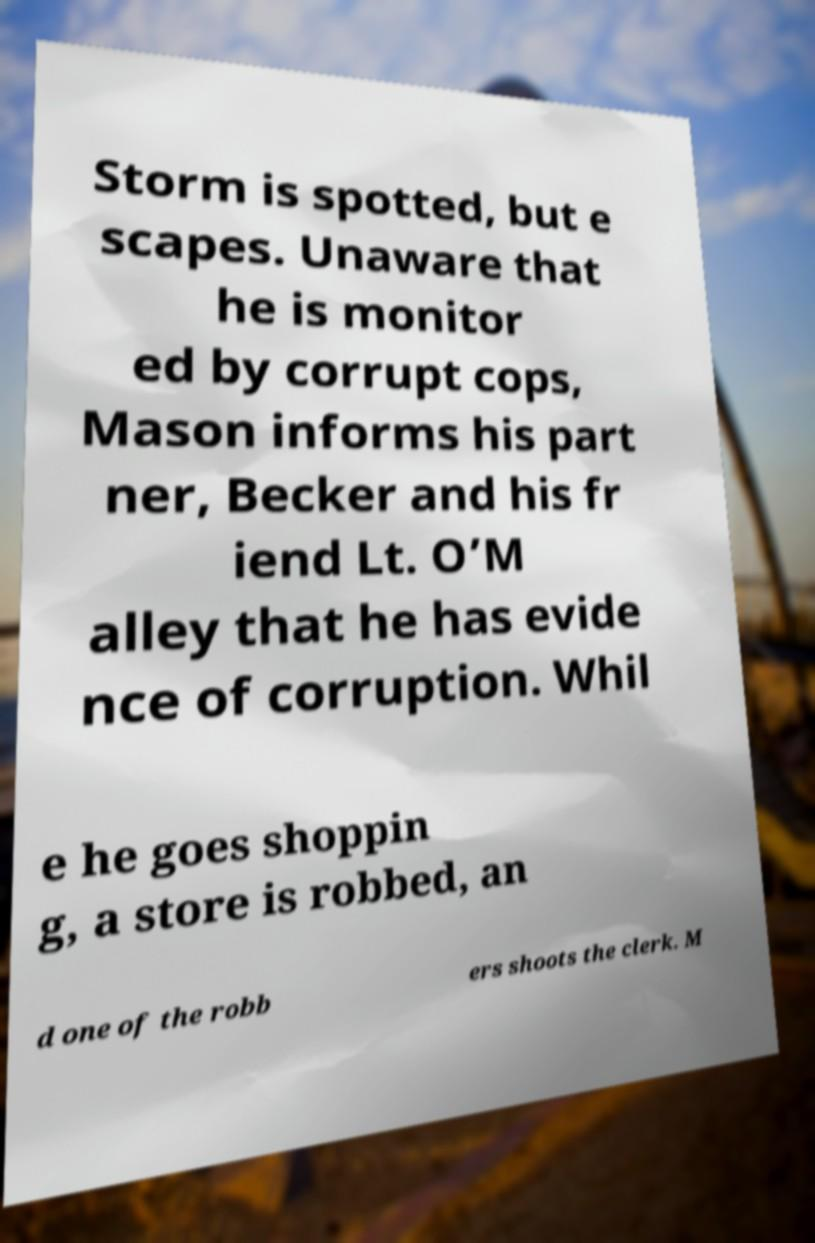For documentation purposes, I need the text within this image transcribed. Could you provide that? Storm is spotted, but e scapes. Unaware that he is monitor ed by corrupt cops, Mason informs his part ner, Becker and his fr iend Lt. O’M alley that he has evide nce of corruption. Whil e he goes shoppin g, a store is robbed, an d one of the robb ers shoots the clerk. M 